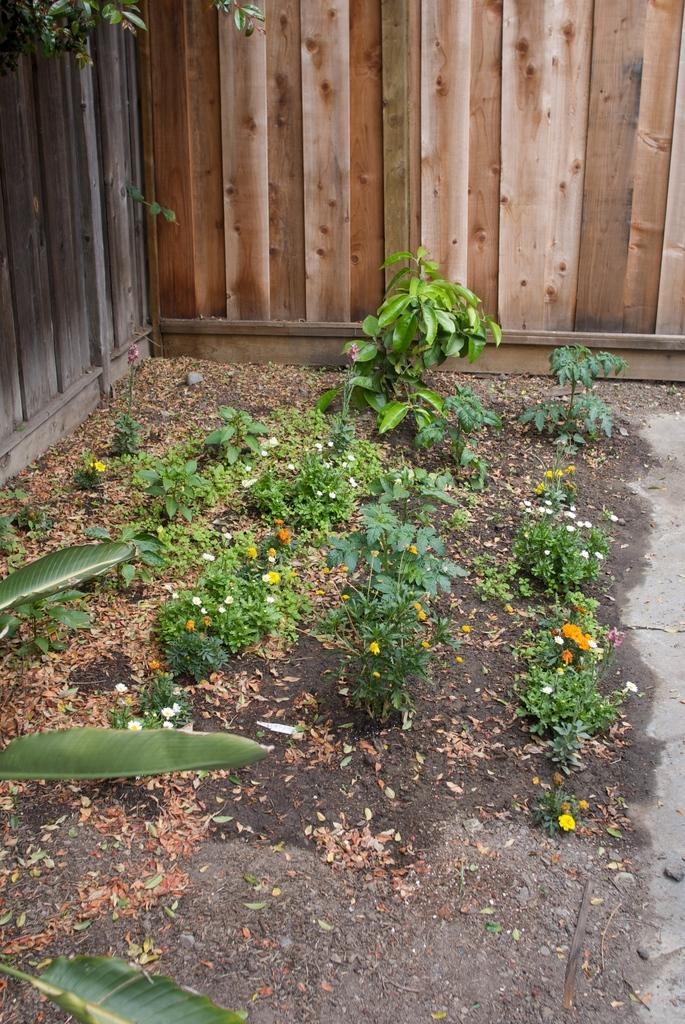What type of vegetation can be seen in the image? There are plants, dried leaves, and flowers visible in the image. What color are the leaves in the image? Green leaves are in the image. What can be seen in the background of the image? There are wooden walls in the background of the image. What type of pencil is being used to draw the country in the image? There is no pencil or drawing of a country present in the image. 